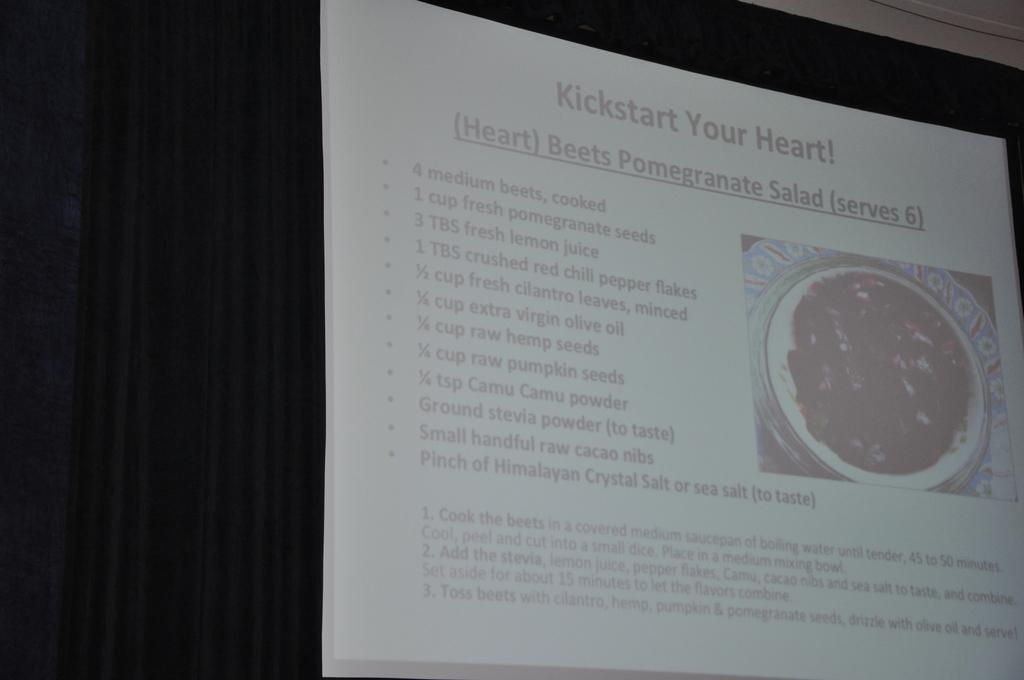What type of covering is present in the image? There is a curtain in the image. What can be seen on the screen in the image? An image is visible on the screen, and there is also text or writing on the screen. What type of government is depicted in the image on the screen? There is no government depicted in the image on the screen, as the facts provided do not mention any political or governmental elements. 